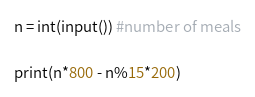Convert code to text. <code><loc_0><loc_0><loc_500><loc_500><_Python_>n = int(input()) #number of meals

print(n*800 - n%15*200)</code> 